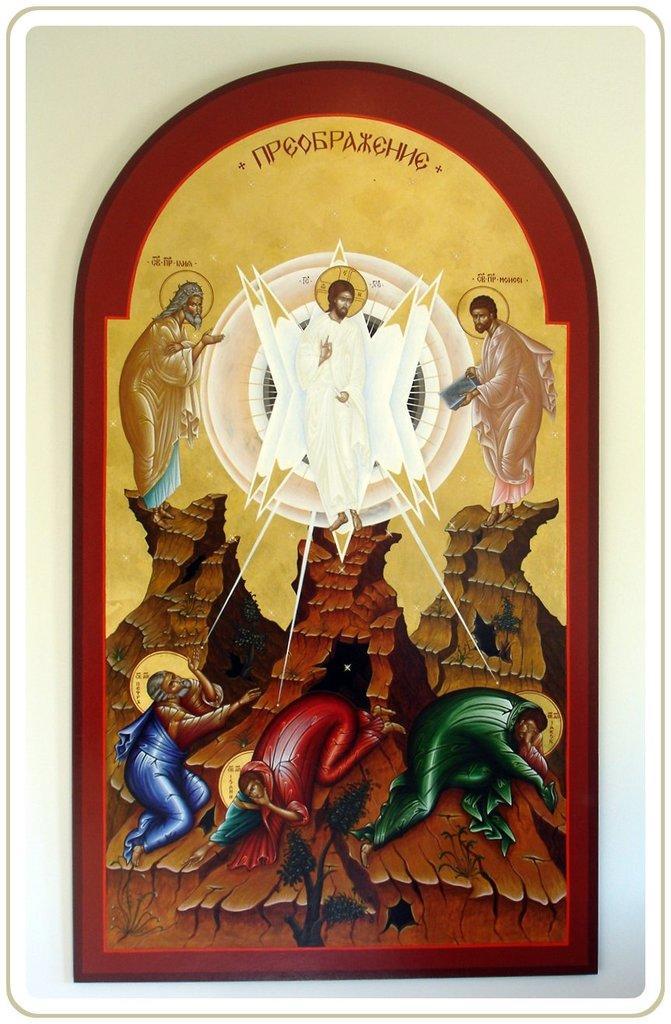Describe this image in one or two sentences. In this image there is a photo frame, there are persons in the photo frame, there is text on the photo frame, at the background of the image there is a wall. 